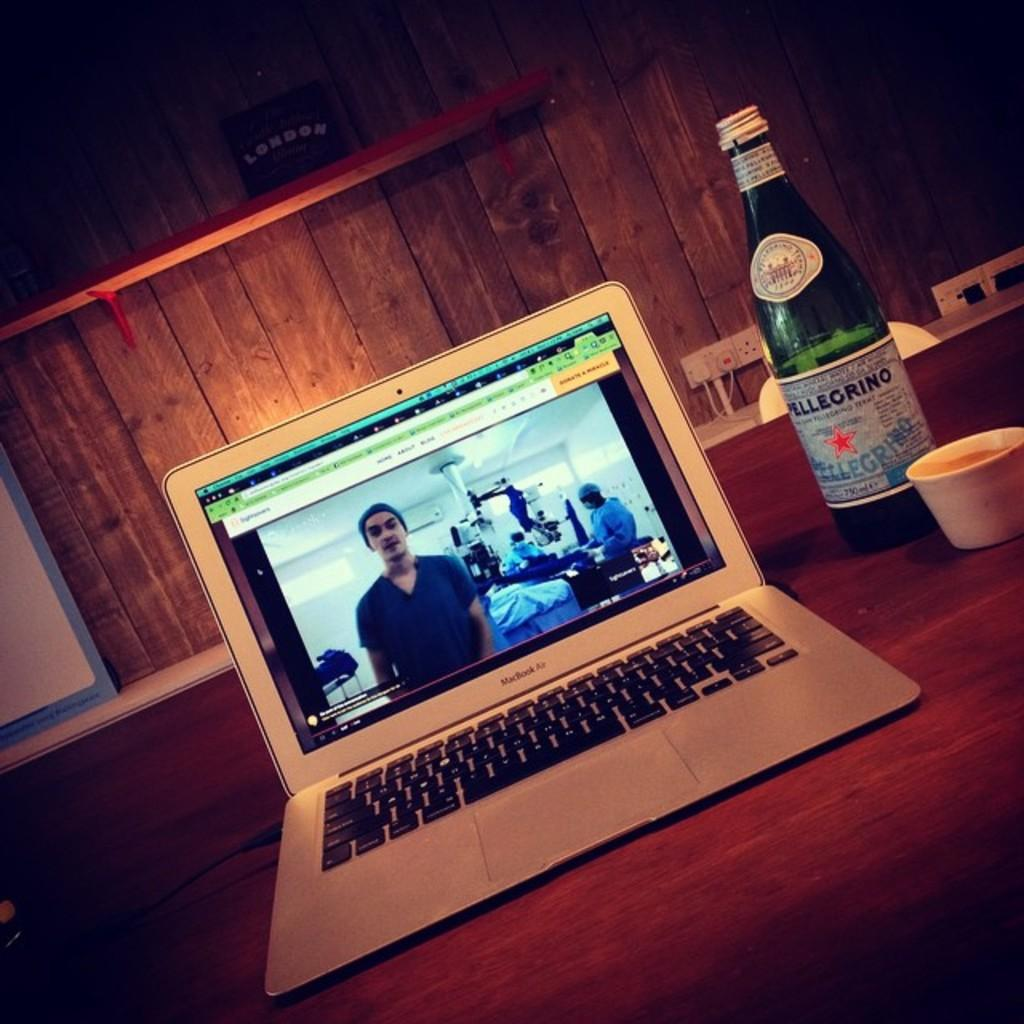What is the main piece of furniture in the image? There is a table in the image. What electronic device is placed on the table? There is a laptop on the table. What other objects are on the table beside the laptop? There is a bottle and a cup on the table beside the laptop. What can be seen in the background of the image? There is a wooden wall in the background of the image. How many pizzas are being served on the table in the image? There are no pizzas present in the image; the objects on the table include a laptop, a bottle, and a cup. 